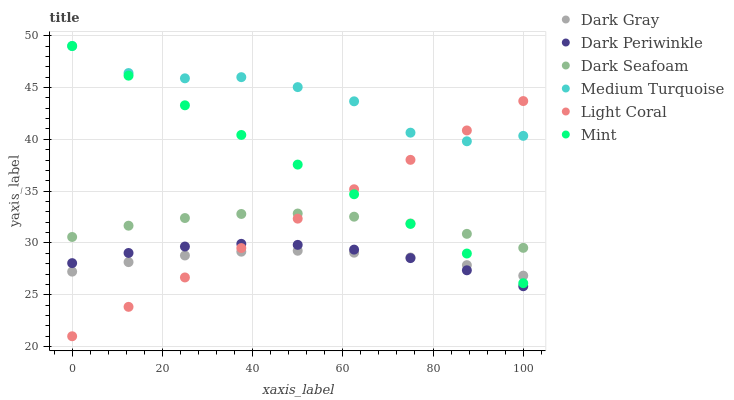Does Dark Gray have the minimum area under the curve?
Answer yes or no. Yes. Does Medium Turquoise have the maximum area under the curve?
Answer yes or no. Yes. Does Dark Seafoam have the minimum area under the curve?
Answer yes or no. No. Does Dark Seafoam have the maximum area under the curve?
Answer yes or no. No. Is Light Coral the smoothest?
Answer yes or no. Yes. Is Medium Turquoise the roughest?
Answer yes or no. Yes. Is Dark Gray the smoothest?
Answer yes or no. No. Is Dark Gray the roughest?
Answer yes or no. No. Does Light Coral have the lowest value?
Answer yes or no. Yes. Does Dark Gray have the lowest value?
Answer yes or no. No. Does Mint have the highest value?
Answer yes or no. Yes. Does Dark Seafoam have the highest value?
Answer yes or no. No. Is Dark Periwinkle less than Medium Turquoise?
Answer yes or no. Yes. Is Medium Turquoise greater than Dark Gray?
Answer yes or no. Yes. Does Dark Gray intersect Light Coral?
Answer yes or no. Yes. Is Dark Gray less than Light Coral?
Answer yes or no. No. Is Dark Gray greater than Light Coral?
Answer yes or no. No. Does Dark Periwinkle intersect Medium Turquoise?
Answer yes or no. No. 